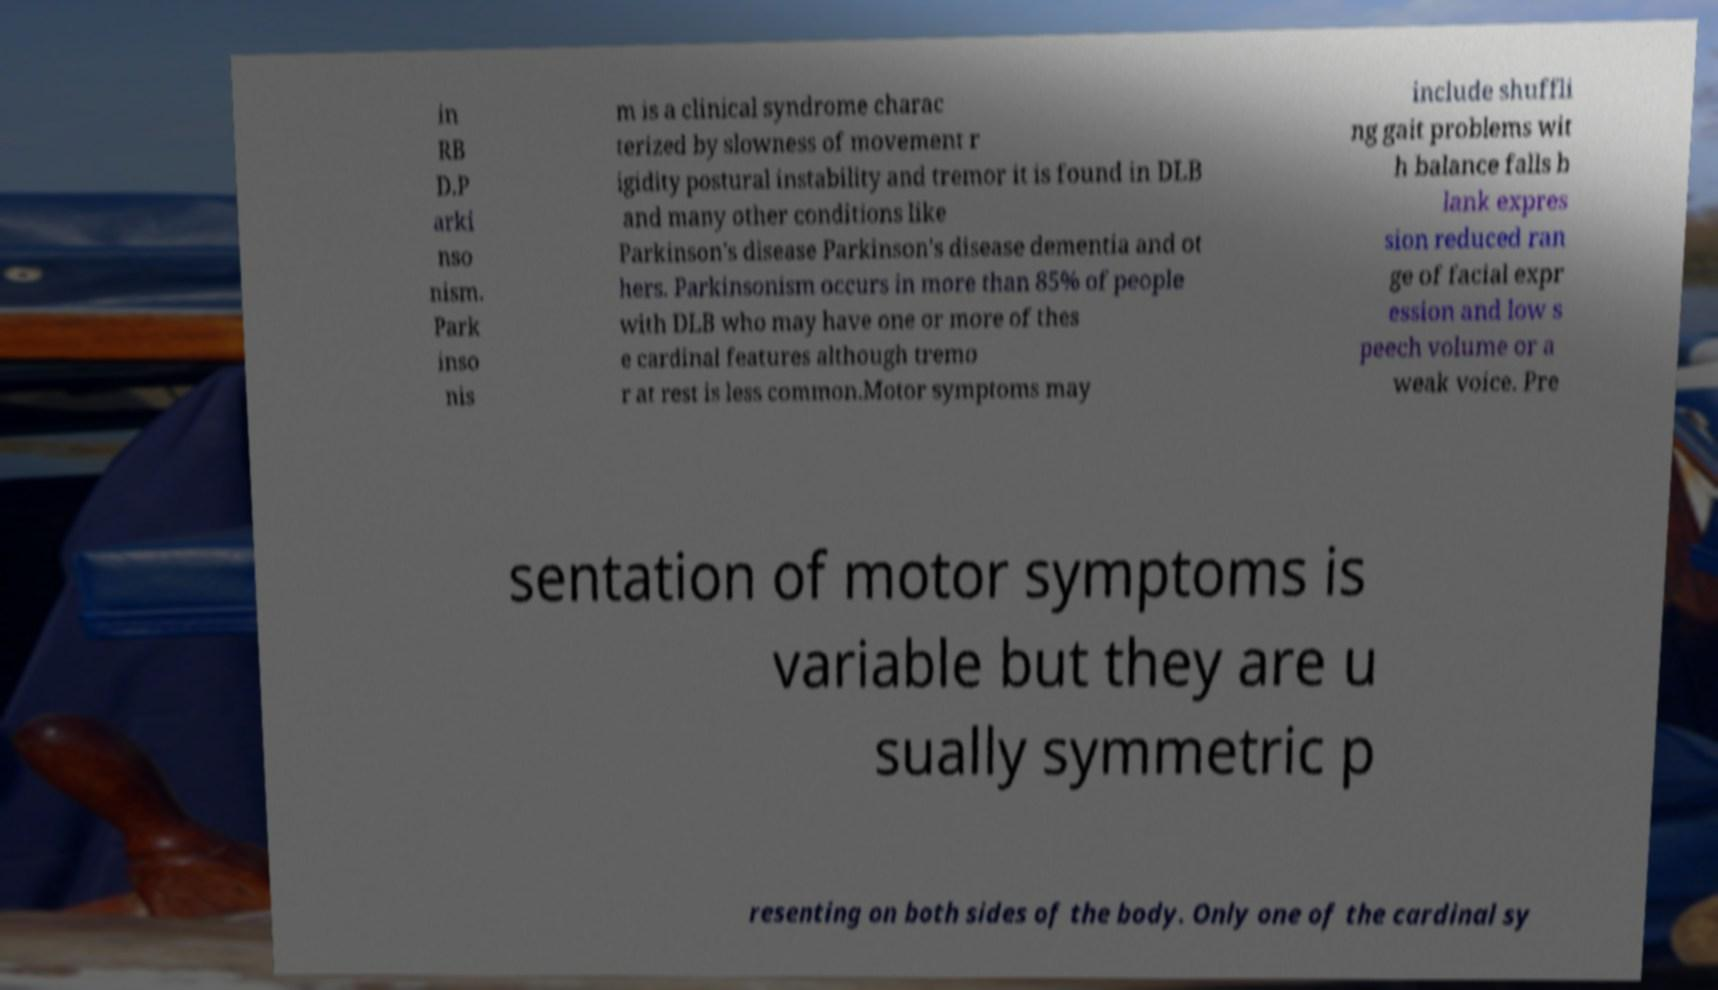Could you assist in decoding the text presented in this image and type it out clearly? in RB D.P arki nso nism. Park inso nis m is a clinical syndrome charac terized by slowness of movement r igidity postural instability and tremor it is found in DLB and many other conditions like Parkinson's disease Parkinson's disease dementia and ot hers. Parkinsonism occurs in more than 85% of people with DLB who may have one or more of thes e cardinal features although tremo r at rest is less common.Motor symptoms may include shuffli ng gait problems wit h balance falls b lank expres sion reduced ran ge of facial expr ession and low s peech volume or a weak voice. Pre sentation of motor symptoms is variable but they are u sually symmetric p resenting on both sides of the body. Only one of the cardinal sy 